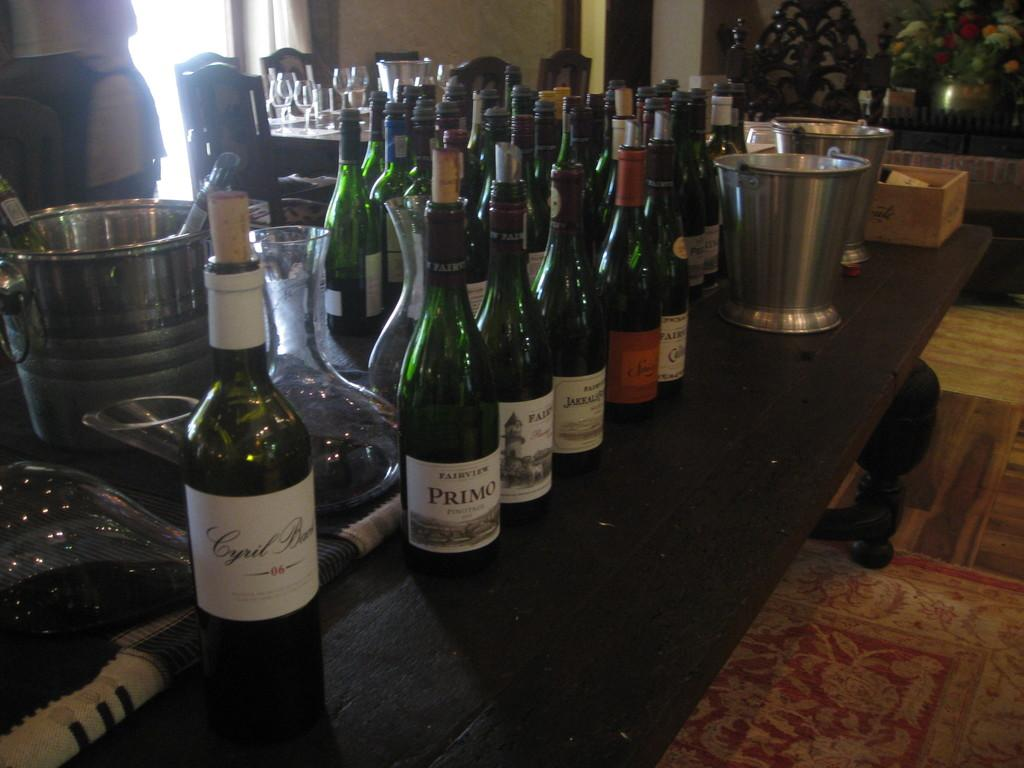<image>
Relay a brief, clear account of the picture shown. the word Primo is on the green bottle 